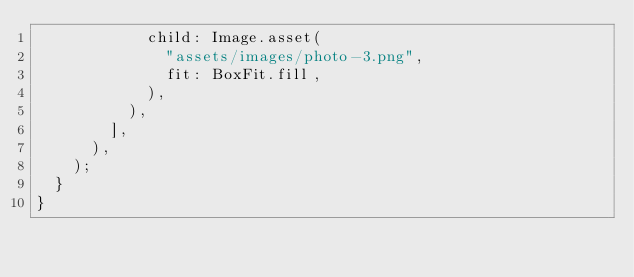Convert code to text. <code><loc_0><loc_0><loc_500><loc_500><_Dart_>            child: Image.asset(
              "assets/images/photo-3.png",
              fit: BoxFit.fill,
            ),
          ),
        ],
      ),
    );
  }
}</code> 